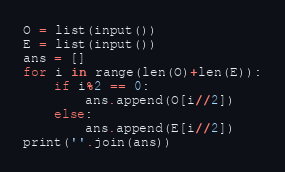<code> <loc_0><loc_0><loc_500><loc_500><_Python_>O = list(input())
E = list(input())
ans = []
for i in range(len(O)+len(E)):
    if i%2 == 0:
        ans.append(O[i//2])
    else:
        ans.append(E[i//2])
print(''.join(ans))</code> 